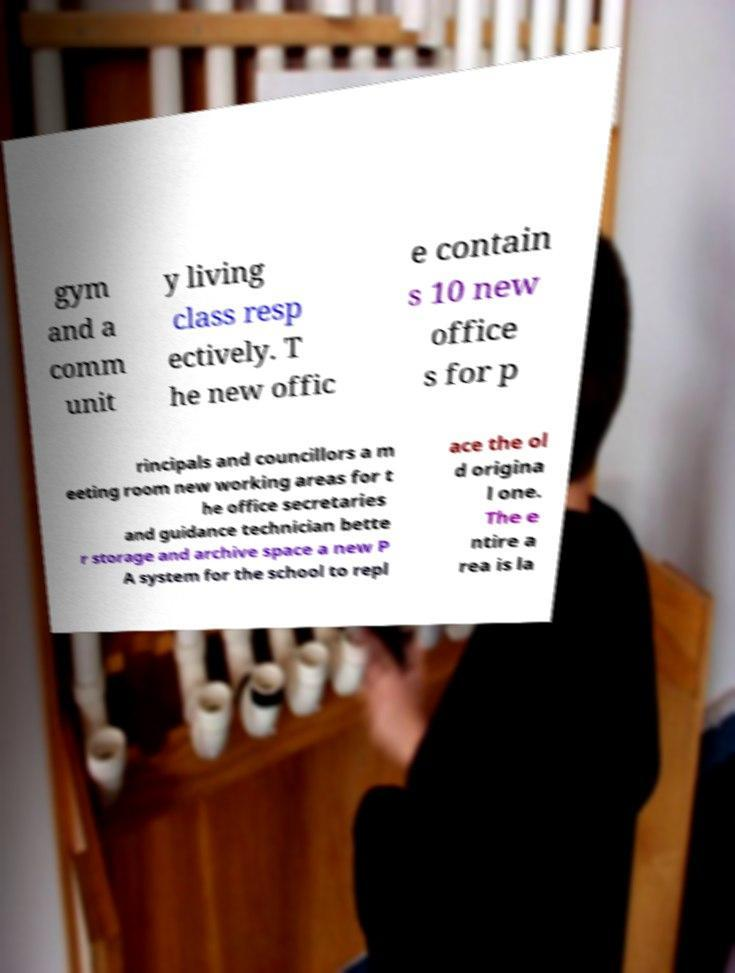Could you assist in decoding the text presented in this image and type it out clearly? gym and a comm unit y living class resp ectively. T he new offic e contain s 10 new office s for p rincipals and councillors a m eeting room new working areas for t he office secretaries and guidance technician bette r storage and archive space a new P A system for the school to repl ace the ol d origina l one. The e ntire a rea is la 